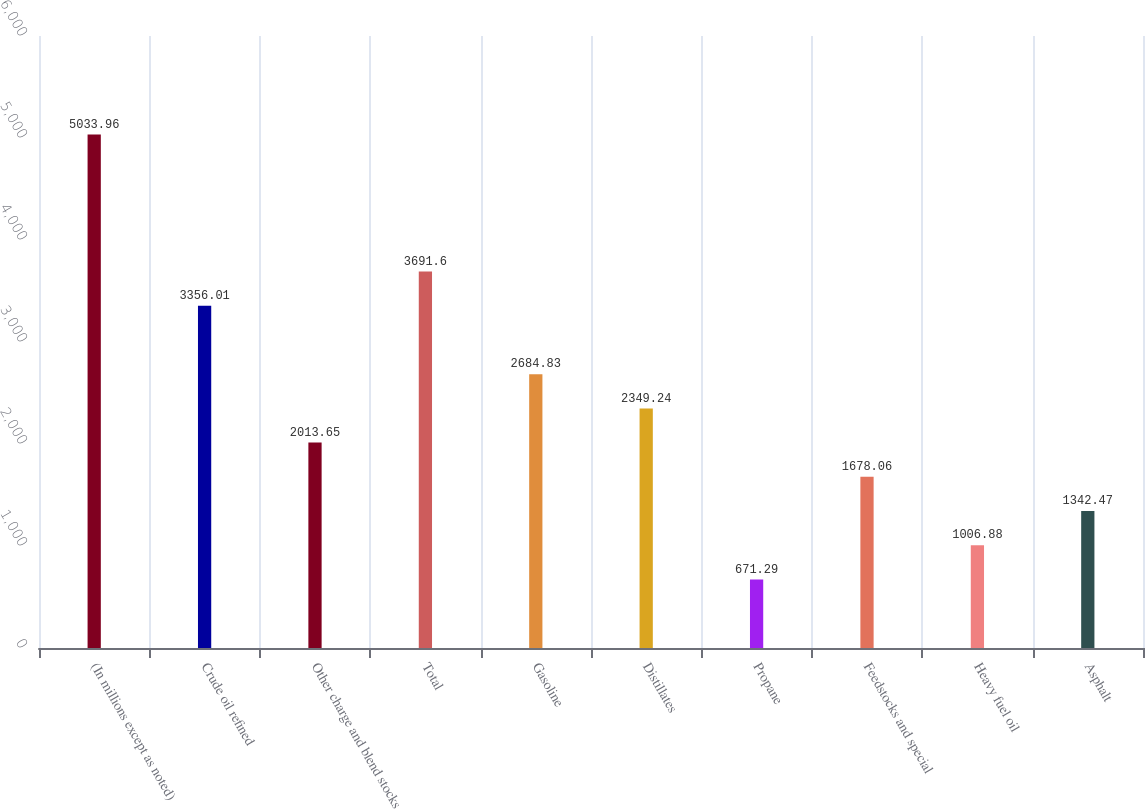<chart> <loc_0><loc_0><loc_500><loc_500><bar_chart><fcel>(In millions except as noted)<fcel>Crude oil refined<fcel>Other charge and blend stocks<fcel>Total<fcel>Gasoline<fcel>Distillates<fcel>Propane<fcel>Feedstocks and special<fcel>Heavy fuel oil<fcel>Asphalt<nl><fcel>5033.96<fcel>3356.01<fcel>2013.65<fcel>3691.6<fcel>2684.83<fcel>2349.24<fcel>671.29<fcel>1678.06<fcel>1006.88<fcel>1342.47<nl></chart> 